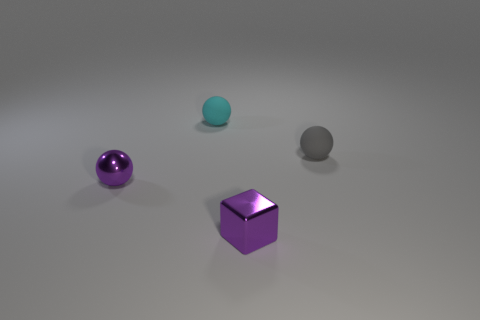Is there a tiny purple ball?
Ensure brevity in your answer.  Yes. There is a small metallic block; is it the same color as the small matte ball on the right side of the tiny purple metallic cube?
Offer a very short reply. No. What color is the metal sphere?
Offer a terse response. Purple. Is there any other thing that is the same shape as the cyan rubber thing?
Offer a terse response. Yes. There is another tiny rubber thing that is the same shape as the tiny gray matte object; what color is it?
Offer a terse response. Cyan. Does the tiny gray thing have the same shape as the tiny cyan matte thing?
Offer a terse response. Yes. What number of cylinders are gray rubber things or blue matte objects?
Ensure brevity in your answer.  0. There is a thing that is made of the same material as the small purple sphere; what color is it?
Give a very brief answer. Purple. There is a purple metallic thing that is to the left of the cyan object; is it the same size as the tiny purple metallic cube?
Give a very brief answer. Yes. Do the small block and the sphere behind the small gray object have the same material?
Make the answer very short. No. 